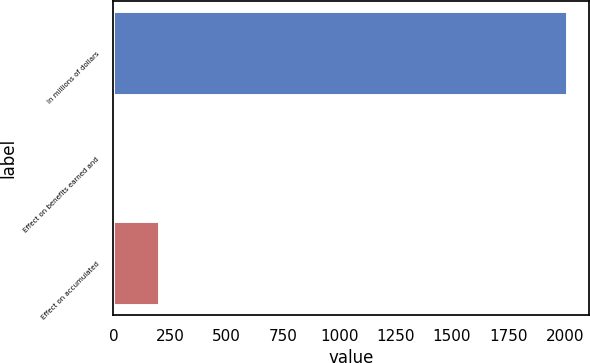<chart> <loc_0><loc_0><loc_500><loc_500><bar_chart><fcel>In millions of dollars<fcel>Effect on benefits earned and<fcel>Effect on accumulated<nl><fcel>2008<fcel>2<fcel>202.6<nl></chart> 